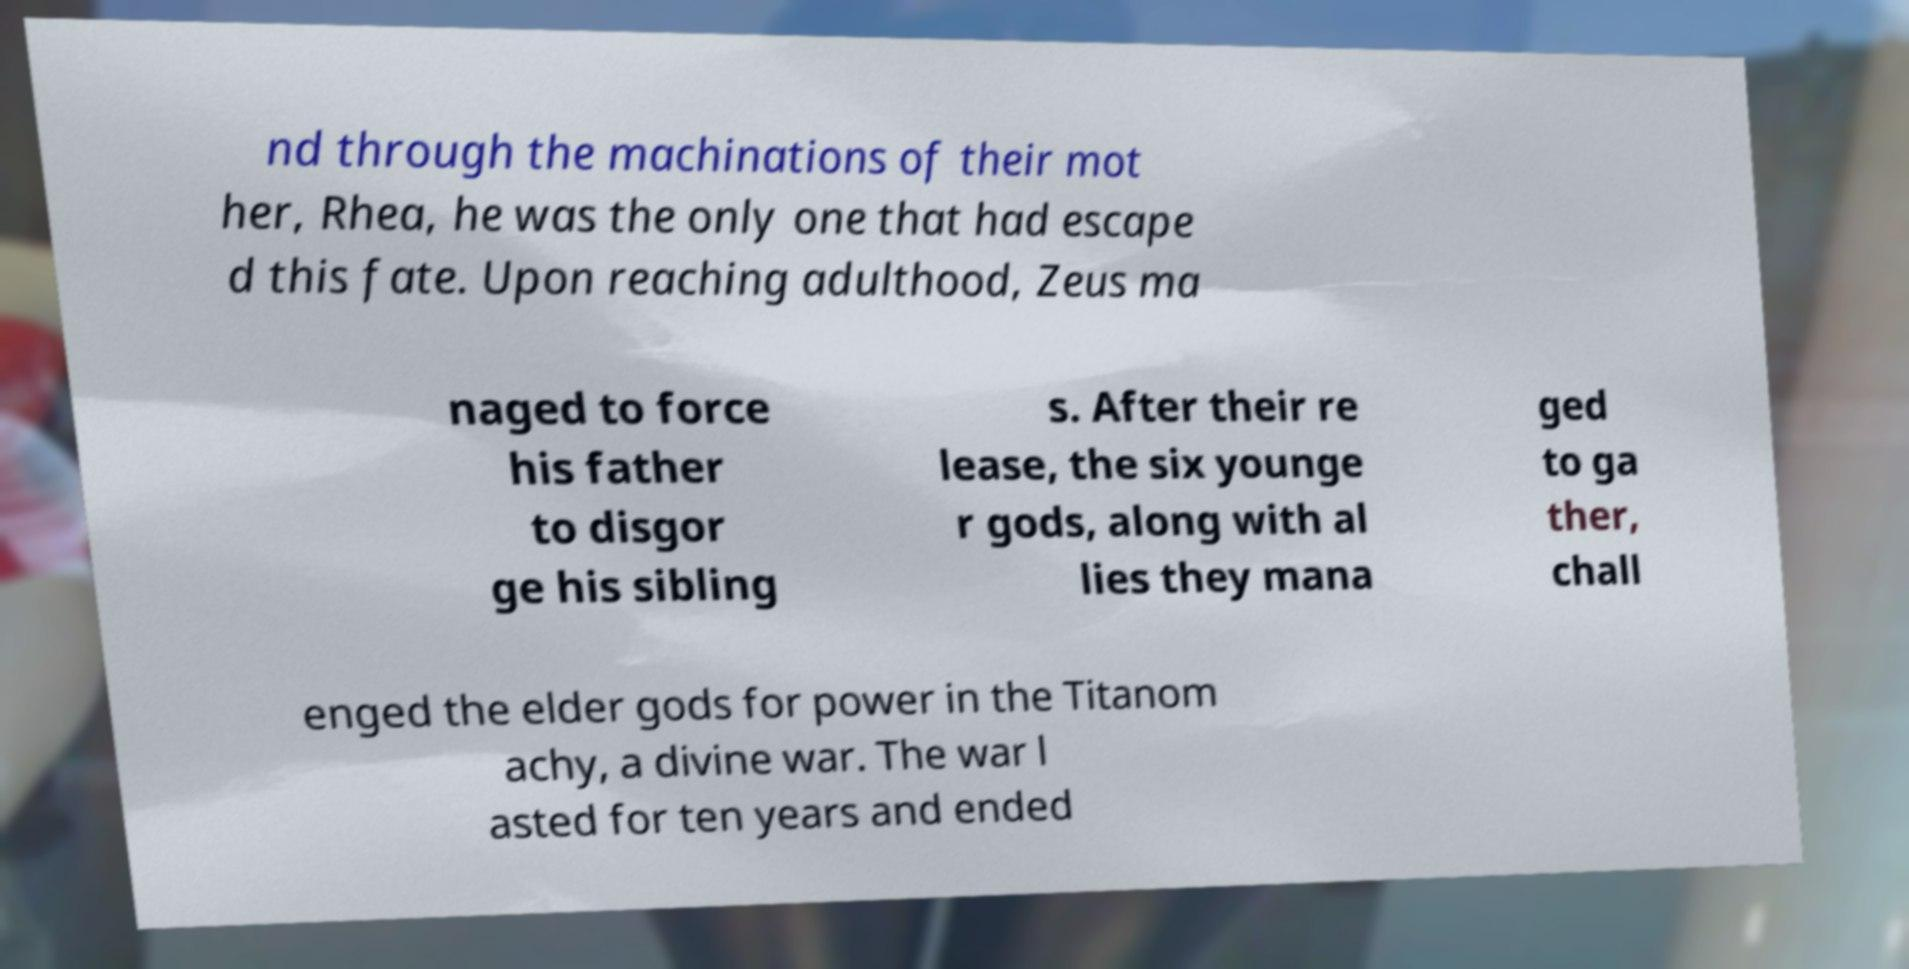For documentation purposes, I need the text within this image transcribed. Could you provide that? nd through the machinations of their mot her, Rhea, he was the only one that had escape d this fate. Upon reaching adulthood, Zeus ma naged to force his father to disgor ge his sibling s. After their re lease, the six younge r gods, along with al lies they mana ged to ga ther, chall enged the elder gods for power in the Titanom achy, a divine war. The war l asted for ten years and ended 